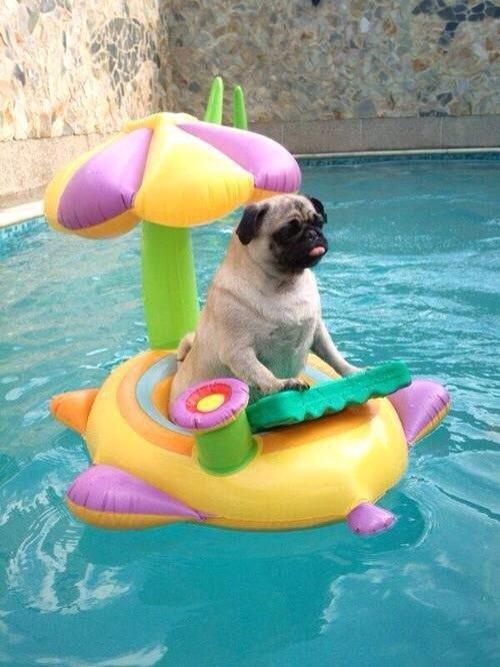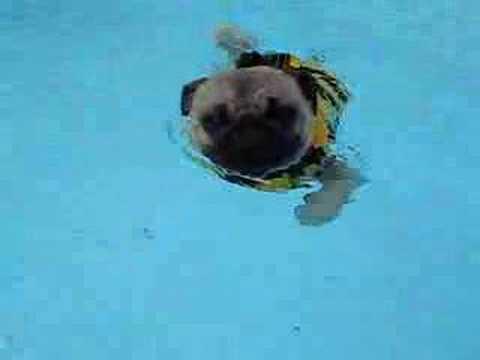The first image is the image on the left, the second image is the image on the right. For the images displayed, is the sentence "A pug wearing a yellowish life vest swims toward the camera." factually correct? Answer yes or no. Yes. The first image is the image on the left, the second image is the image on the right. Given the left and right images, does the statement "Two pug dogs are seen in a swimming pool, one of them riding above the water on an inflatable flotation device, while the other is in the water swimming." hold true? Answer yes or no. Yes. 